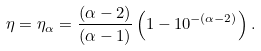Convert formula to latex. <formula><loc_0><loc_0><loc_500><loc_500>\eta = \eta _ { \alpha } = \frac { ( \alpha - 2 ) } { ( \alpha - 1 ) } \left ( 1 - 1 0 ^ { - ( \alpha - 2 ) } \right ) .</formula> 